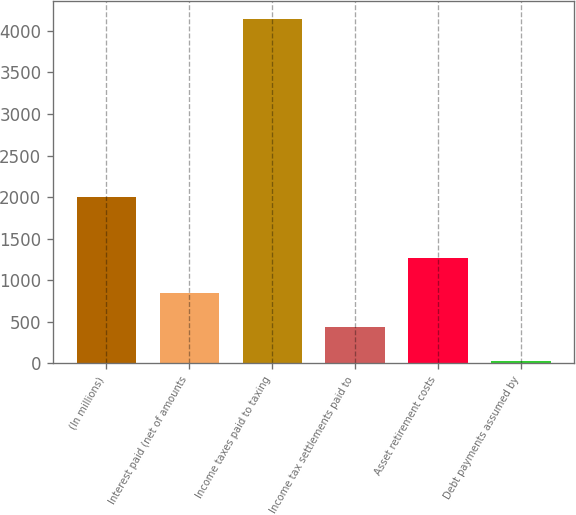Convert chart. <chart><loc_0><loc_0><loc_500><loc_500><bar_chart><fcel>(In millions)<fcel>Interest paid (net of amounts<fcel>Income taxes paid to taxing<fcel>Income tax settlements paid to<fcel>Asset retirement costs<fcel>Debt payments assumed by<nl><fcel>2006<fcel>849<fcel>4149<fcel>436.5<fcel>1261.5<fcel>24<nl></chart> 